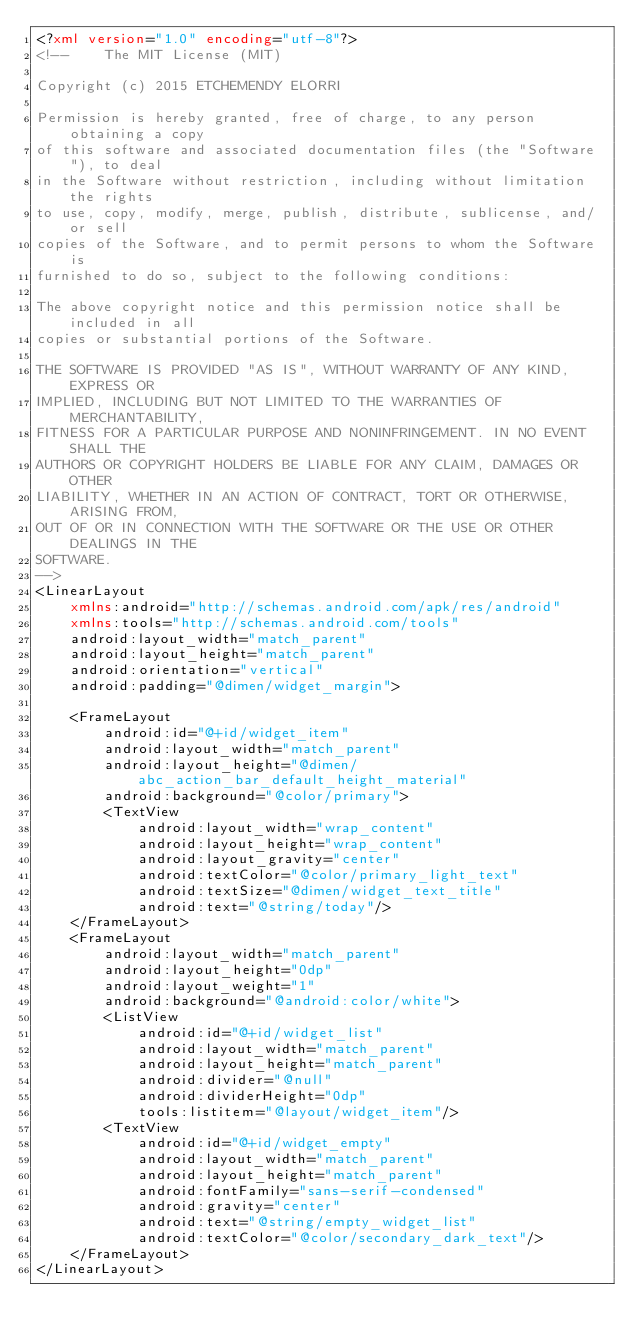<code> <loc_0><loc_0><loc_500><loc_500><_XML_><?xml version="1.0" encoding="utf-8"?>
<!-- 	The MIT License (MIT)

Copyright (c) 2015 ETCHEMENDY ELORRI

Permission is hereby granted, free of charge, to any person obtaining a copy
of this software and associated documentation files (the "Software"), to deal
in the Software without restriction, including without limitation the rights
to use, copy, modify, merge, publish, distribute, sublicense, and/or sell
copies of the Software, and to permit persons to whom the Software is
furnished to do so, subject to the following conditions:

The above copyright notice and this permission notice shall be included in all
copies or substantial portions of the Software.

THE SOFTWARE IS PROVIDED "AS IS", WITHOUT WARRANTY OF ANY KIND, EXPRESS OR
IMPLIED, INCLUDING BUT NOT LIMITED TO THE WARRANTIES OF MERCHANTABILITY,
FITNESS FOR A PARTICULAR PURPOSE AND NONINFRINGEMENT. IN NO EVENT SHALL THE
AUTHORS OR COPYRIGHT HOLDERS BE LIABLE FOR ANY CLAIM, DAMAGES OR OTHER
LIABILITY, WHETHER IN AN ACTION OF CONTRACT, TORT OR OTHERWISE, ARISING FROM,
OUT OF OR IN CONNECTION WITH THE SOFTWARE OR THE USE OR OTHER DEALINGS IN THE
SOFTWARE.
-->
<LinearLayout
    xmlns:android="http://schemas.android.com/apk/res/android"
    xmlns:tools="http://schemas.android.com/tools"
    android:layout_width="match_parent"
    android:layout_height="match_parent"
    android:orientation="vertical"
    android:padding="@dimen/widget_margin">

    <FrameLayout
        android:id="@+id/widget_item"
        android:layout_width="match_parent"
        android:layout_height="@dimen/abc_action_bar_default_height_material"
        android:background="@color/primary">
        <TextView
            android:layout_width="wrap_content"
            android:layout_height="wrap_content"
            android:layout_gravity="center"
            android:textColor="@color/primary_light_text"
            android:textSize="@dimen/widget_text_title"
            android:text="@string/today"/>
    </FrameLayout>
    <FrameLayout
        android:layout_width="match_parent"
        android:layout_height="0dp"
        android:layout_weight="1"
        android:background="@android:color/white">
        <ListView
            android:id="@+id/widget_list"
            android:layout_width="match_parent"
            android:layout_height="match_parent"
            android:divider="@null"
            android:dividerHeight="0dp"
            tools:listitem="@layout/widget_item"/>
        <TextView
            android:id="@+id/widget_empty"
            android:layout_width="match_parent"
            android:layout_height="match_parent"
            android:fontFamily="sans-serif-condensed"
            android:gravity="center"
            android:text="@string/empty_widget_list"
            android:textColor="@color/secondary_dark_text"/>
    </FrameLayout>
</LinearLayout></code> 